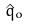Convert formula to latex. <formula><loc_0><loc_0><loc_500><loc_500>\hat { q } _ { o }</formula> 